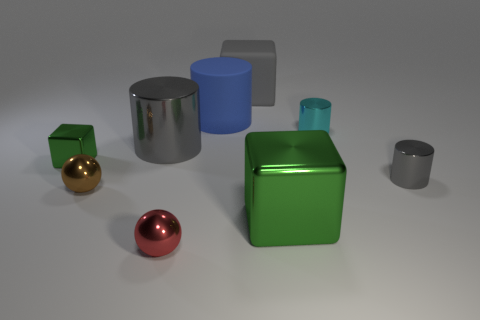Subtract 1 cylinders. How many cylinders are left? 3 Add 1 large gray shiny things. How many objects exist? 10 Subtract all cubes. How many objects are left? 6 Add 1 small brown shiny objects. How many small brown shiny objects exist? 2 Subtract 0 brown cylinders. How many objects are left? 9 Subtract all small cyan objects. Subtract all big gray cylinders. How many objects are left? 7 Add 2 large green metallic things. How many large green metallic things are left? 3 